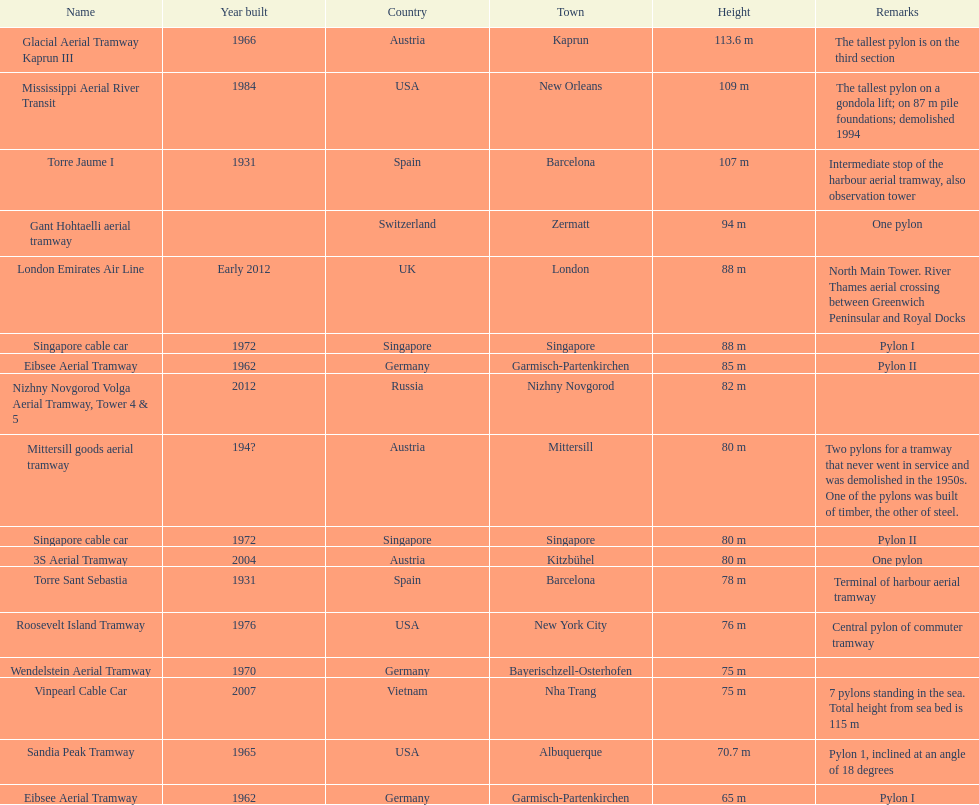What is the total number of pylons listed? 17. 